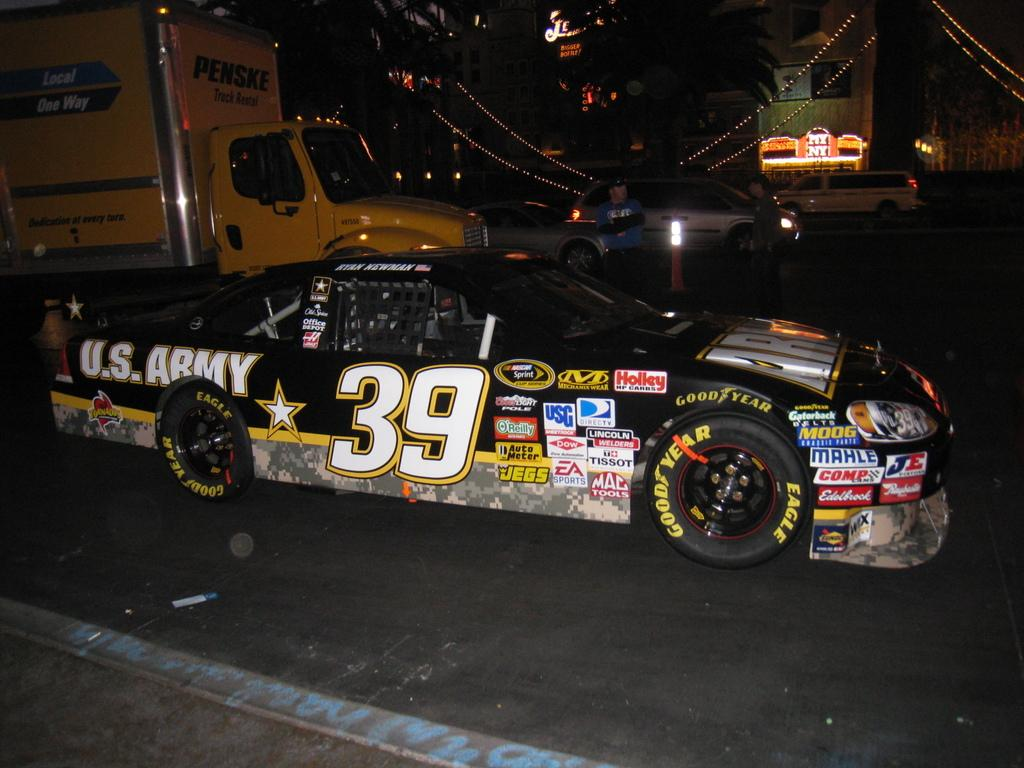What types of vehicles can be seen on the road in the image? There are cars and trucks on the road in the image. What is located on the other side of the road in the image? There are trees and buildings on the other side of the road in the image. How many pins are holding the system together in the image? There are no pins or systems present in the image; it features vehicles on a road with trees and buildings on the other side. 